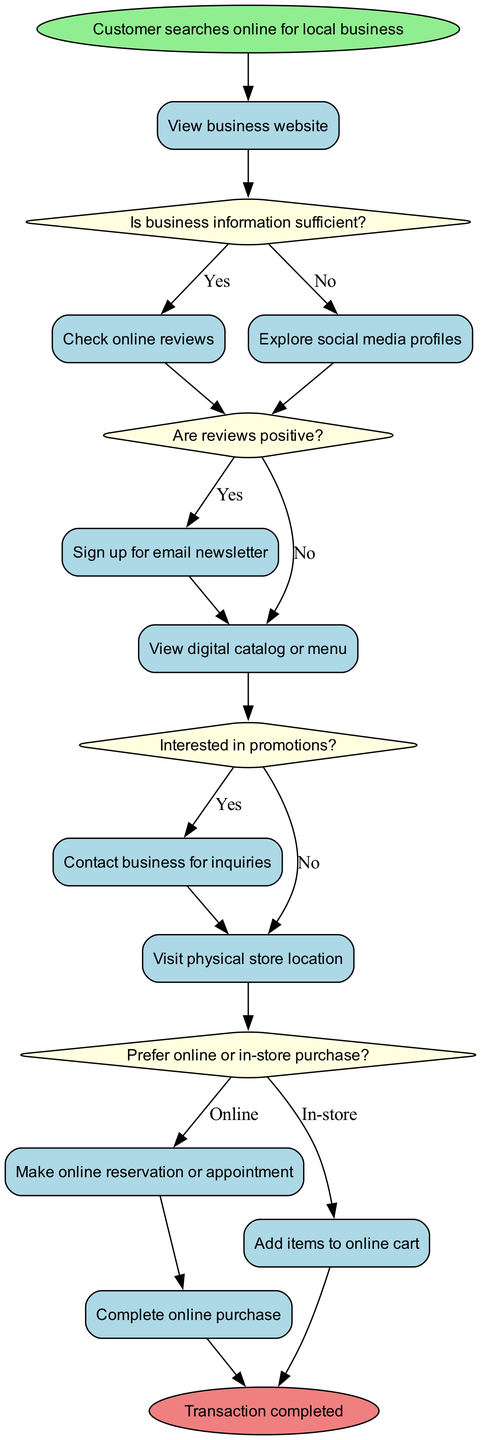What is the initial node in the diagram? The initial node is explicitly labeled in the diagram as "Customer searches online for local business." Therefore, it represents the starting point of the customer journey.
Answer: Customer searches online for local business How many activities are represented in the diagram? The diagram contains a list of activities that can be counted. There are 10 activities listed, indicating all the steps the customer can take after the initial node.
Answer: 10 What decision follows the “View business website” activity? The activity "View business website" connects directly to the decision labeled "Is business information sufficient?" This means this decision is the next step in the customer journey.
Answer: Is business information sufficient? What happens if the customer finds business information sufficient? If the customer determines that the business information is sufficient (answering "Yes" to the associated decision), the flow continues to the “Check online reviews” activity, which indicates they are looking for customer feedback next.
Answer: Check online reviews Which activity follows the “Interested in promotions?” decision if the answer is no? The decision "Interested in promotions?" has two branches. If the customer answers “No,” the flow leads to the activity “Prefer online or in-store purchase?” representing a shift to choosing the purchasing method.
Answer: Prefer online or in-store purchase? If the customer chooses "In-store" after visiting the physical store, what is the next action? After the customer decides on the in-store purchase option, the next action indicated in the diagram is to “Complete online purchase” which signifies the process of finalizing the transaction.
Answer: Complete online purchase What is the final node in the customer journey? The final node is denoted as "Transaction completed," marking the endpoint of the customer journey, indicating that the purchase process is finalized.
Answer: Transaction completed How many decisions are present in the diagram? A count of the decisions yields a total of 4 distinct decision nodes, illustrating key points where the customer must make choices based on their shopping experience.
Answer: 4 What do customers do after “Contact business for inquiries”? Following the activity "Contact business for inquiries," the customer then has the option to proceed to “Visit physical store location,” as shown in the diagram.
Answer: Visit physical store location 